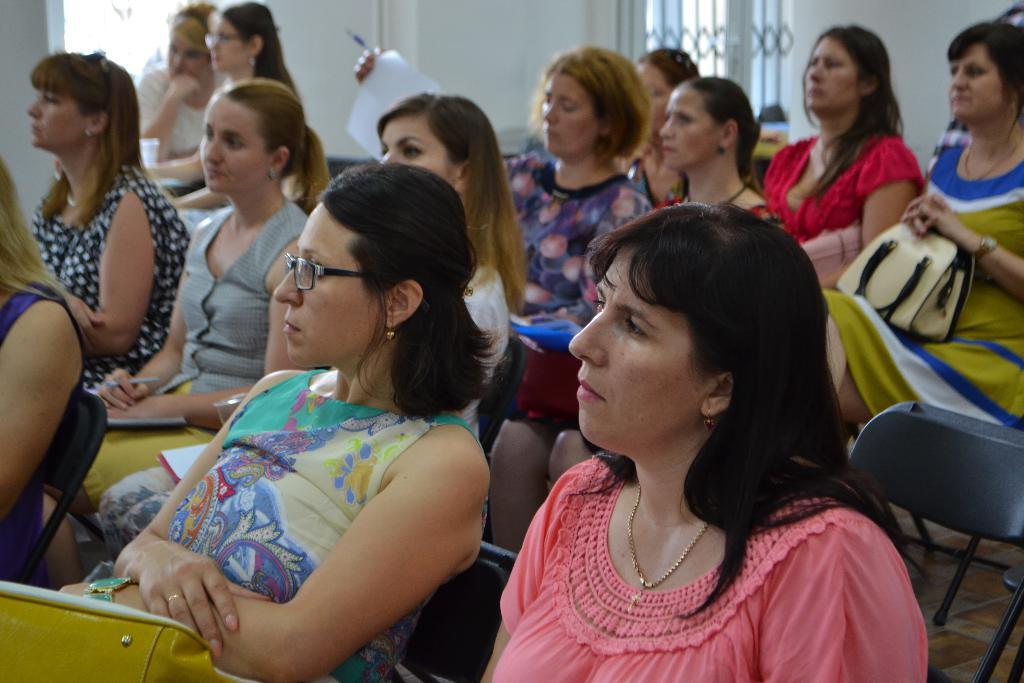What is happening in the image? There is a group of people in the image, and they are sitting. What can be seen in the background of the image? There is a wall in the background of the image. What type of coil is being used by the people in the image? There is no coil present in the image; the people are simply sitting. 